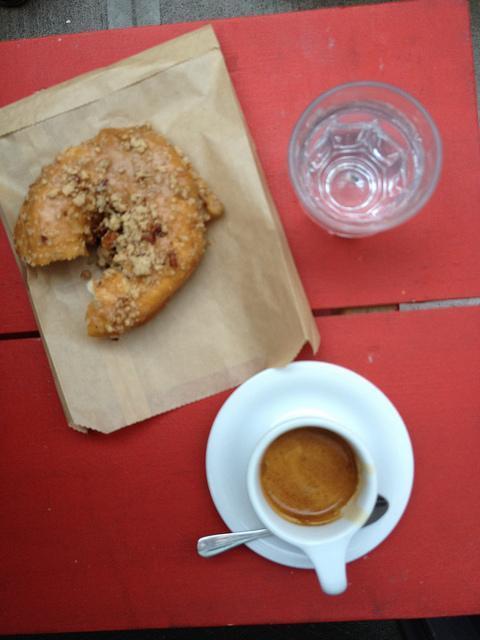How many donuts are picture?
Give a very brief answer. 1. How many cups can you see?
Give a very brief answer. 2. 